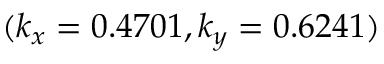<formula> <loc_0><loc_0><loc_500><loc_500>( k _ { x } = 0 . 4 7 0 1 , k _ { y } = 0 . 6 2 4 1 )</formula> 